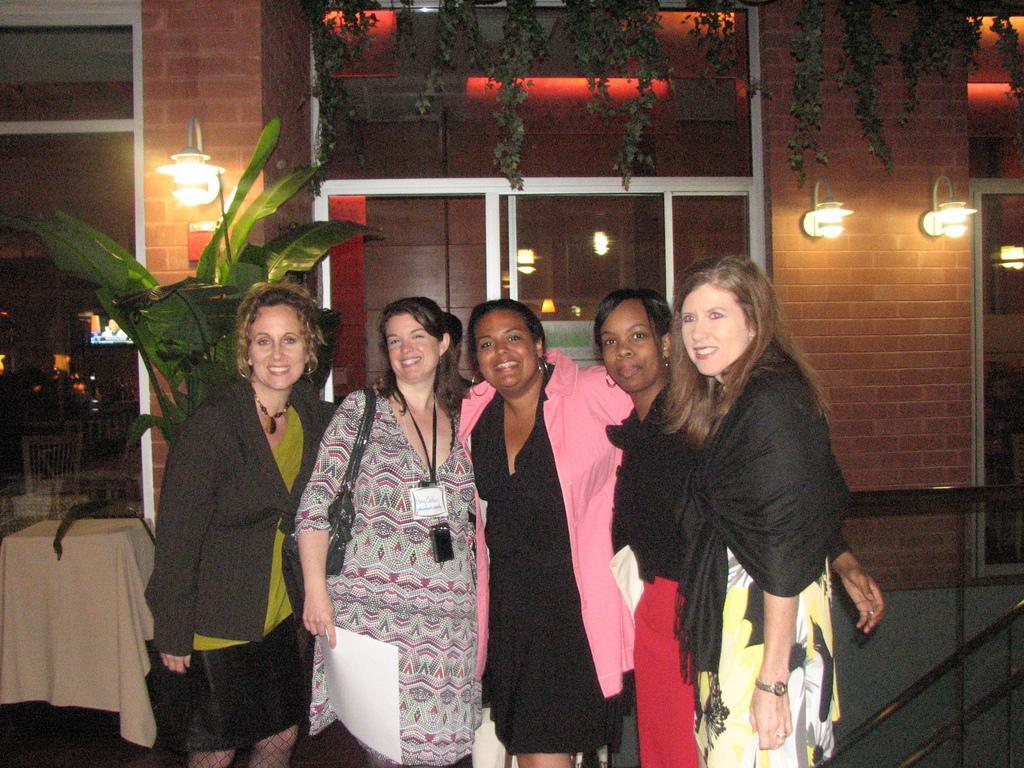How would you summarize this image in a sentence or two? In this image I see 5 women and all of them are smiling. In the background I see lights on the wall and plants and a door. 